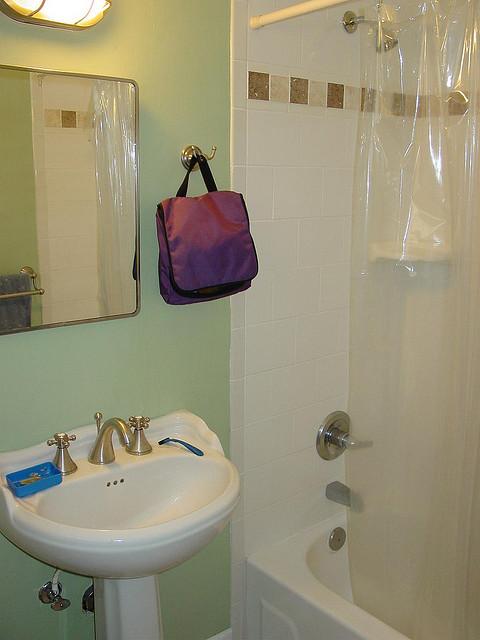What color is the shower curtain?
Answer briefly. Clear. Does the clean appear clean?
Write a very short answer. Yes. What color is the bag hanging on the hook?
Quick response, please. Purple. 